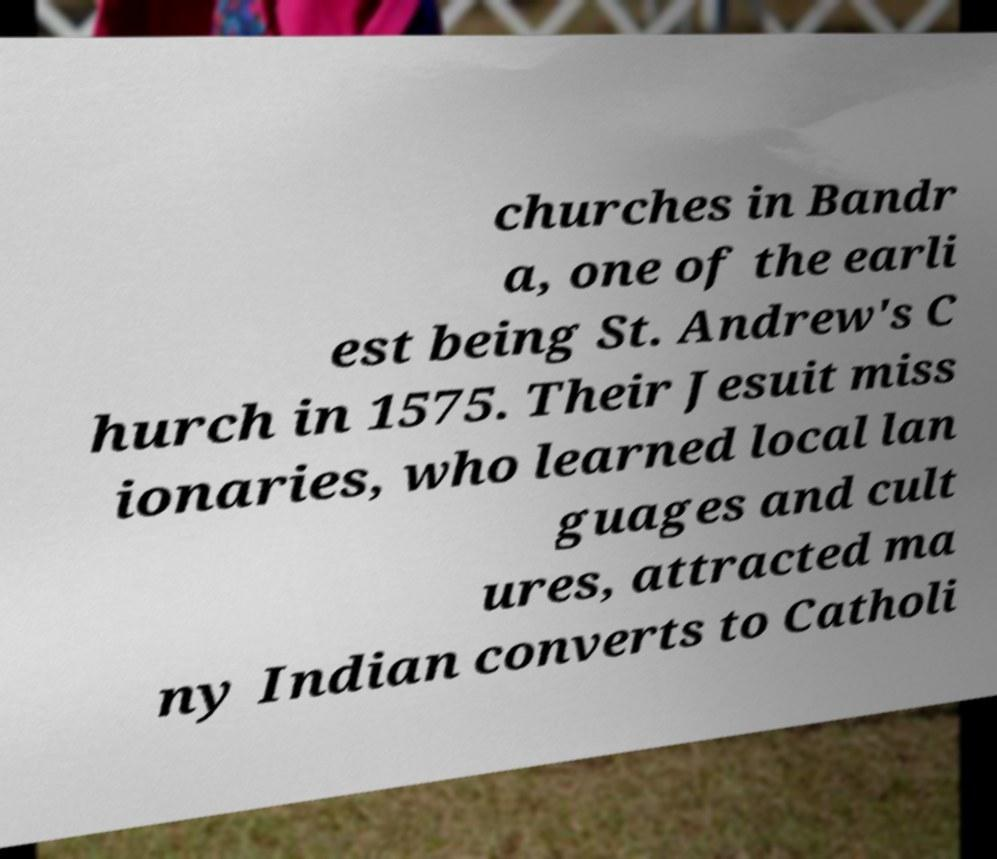Could you assist in decoding the text presented in this image and type it out clearly? churches in Bandr a, one of the earli est being St. Andrew's C hurch in 1575. Their Jesuit miss ionaries, who learned local lan guages and cult ures, attracted ma ny Indian converts to Catholi 